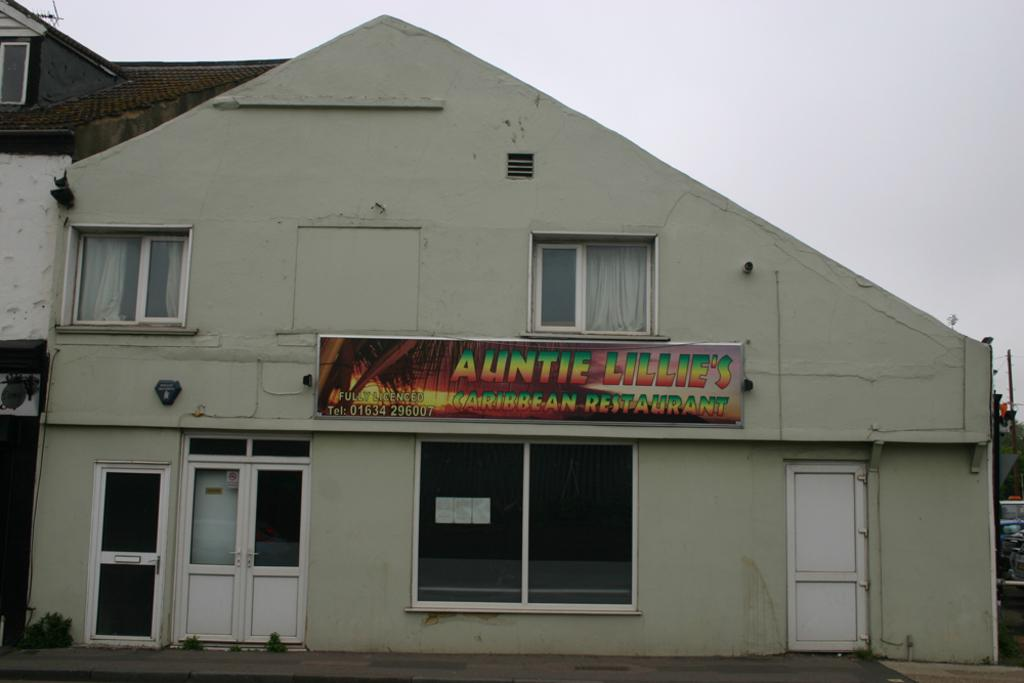What type of structure is visible in the image? There is a building in the image. What is located on the board in the image? The facts do not specify what is on the board, so we cannot answer that question definitively. What architectural features can be seen in the image? There are windows, curtains, and doors visible in the image. What is visible in the background of the image? The sky is visible in the background of the image. Where is the toothbrush located in the image? There is no toothbrush present in the image. What is the topic of the argument taking place in the image? There is no argument present in the image. 